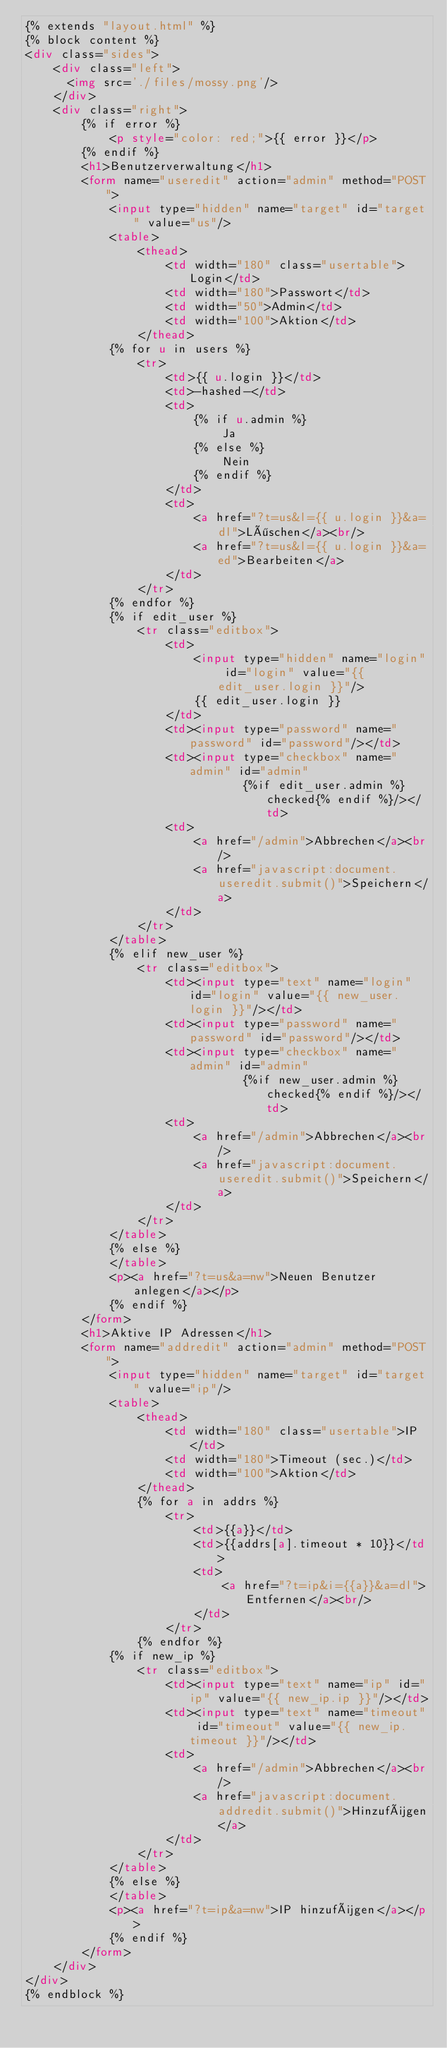Convert code to text. <code><loc_0><loc_0><loc_500><loc_500><_HTML_>{% extends "layout.html" %}
{% block content %}
<div class="sides">
    <div class="left">
      <img src='./files/mossy.png'/>
    </div>
    <div class="right">
        {% if error %}
            <p style="color: red;">{{ error }}</p>
        {% endif %}
        <h1>Benutzerverwaltung</h1>
        <form name="useredit" action="admin" method="POST">
            <input type="hidden" name="target" id="target" value="us"/>
            <table>
                <thead>
                    <td width="180" class="usertable">Login</td>
                    <td width="180">Passwort</td>
                    <td width="50">Admin</td>
                    <td width="100">Aktion</td>
                </thead>
            {% for u in users %}
                <tr>
                    <td>{{ u.login }}</td>
                    <td>-hashed-</td>
                    <td>
                        {% if u.admin %}
                            Ja
                        {% else %}
                            Nein
                        {% endif %}
                    </td>
                    <td>
                        <a href="?t=us&l={{ u.login }}&a=dl">Löschen</a><br/>
                        <a href="?t=us&l={{ u.login }}&a=ed">Bearbeiten</a>
                    </td>
                </tr>
            {% endfor %}
            {% if edit_user %}
                <tr class="editbox">
                    <td>
                        <input type="hidden" name="login" id="login" value="{{ edit_user.login }}"/>
                        {{ edit_user.login }}
                    </td>
                    <td><input type="password" name="password" id="password"/></td>
                    <td><input type="checkbox" name="admin" id="admin"
                               {%if edit_user.admin %}checked{% endif %}/></td>
                    <td>
                        <a href="/admin">Abbrechen</a><br/>
                        <a href="javascript:document.useredit.submit()">Speichern</a>
                    </td>
                </tr>
            </table>
            {% elif new_user %}
                <tr class="editbox">
                    <td><input type="text" name="login" id="login" value="{{ new_user.login }}"/></td>
                    <td><input type="password" name="password" id="password"/></td>
                    <td><input type="checkbox" name="admin" id="admin"
                               {%if new_user.admin %}checked{% endif %}/></td>
                    <td>
                        <a href="/admin">Abbrechen</a><br/>
                        <a href="javascript:document.useredit.submit()">Speichern</a>
                    </td>
                </tr>
            </table>
            {% else %}
            </table>
            <p><a href="?t=us&a=nw">Neuen Benutzer anlegen</a></p>
            {% endif %}
        </form>
        <h1>Aktive IP Adressen</h1>
        <form name="addredit" action="admin" method="POST">
            <input type="hidden" name="target" id="target" value="ip"/>
            <table>
                <thead>
                    <td width="180" class="usertable">IP</td>
                    <td width="180">Timeout (sec.)</td>
                    <td width="100">Aktion</td>
                </thead>
                {% for a in addrs %}
                    <tr>
                        <td>{{a}}</td>
                        <td>{{addrs[a].timeout * 10}}</td>
                        <td>
                            <a href="?t=ip&i={{a}}&a=dl">Entfernen</a><br/>
                        </td>
                    </tr>
                {% endfor %}
            {% if new_ip %}
                <tr class="editbox">
                    <td><input type="text" name="ip" id="ip" value="{{ new_ip.ip }}"/></td>
                    <td><input type="text" name="timeout" id="timeout" value="{{ new_ip.timeout }}"/></td>
                    <td>
                        <a href="/admin">Abbrechen</a><br/>
                        <a href="javascript:document.addredit.submit()">Hinzufügen</a>
                    </td>
                </tr>
            </table>
            {% else %}
            </table>
            <p><a href="?t=ip&a=nw">IP hinzufügen</a></p>
            {% endif %}
        </form>
    </div>
</div>
{% endblock %}
</code> 